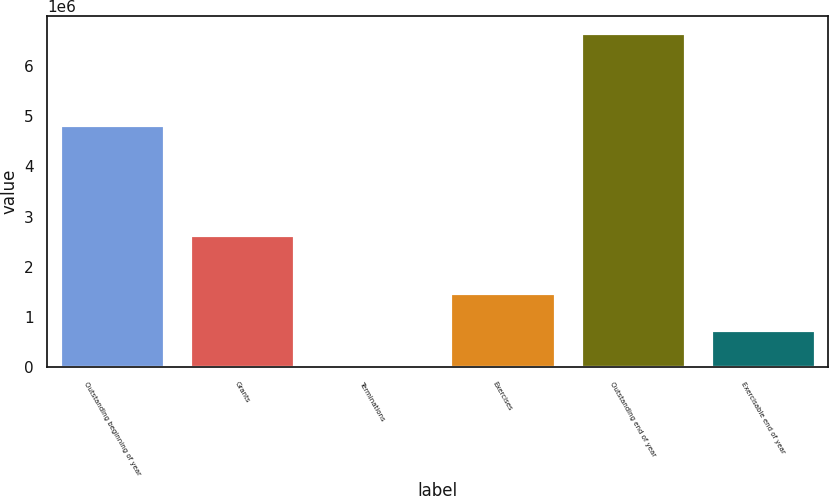Convert chart. <chart><loc_0><loc_0><loc_500><loc_500><bar_chart><fcel>Outstanding beginning of year<fcel>Grants<fcel>Terminations<fcel>Exercises<fcel>Outstanding end of year<fcel>Exercisable end of year<nl><fcel>4.82735e+06<fcel>2.636e+06<fcel>19250<fcel>1.47795e+06<fcel>6.66097e+06<fcel>745336<nl></chart> 